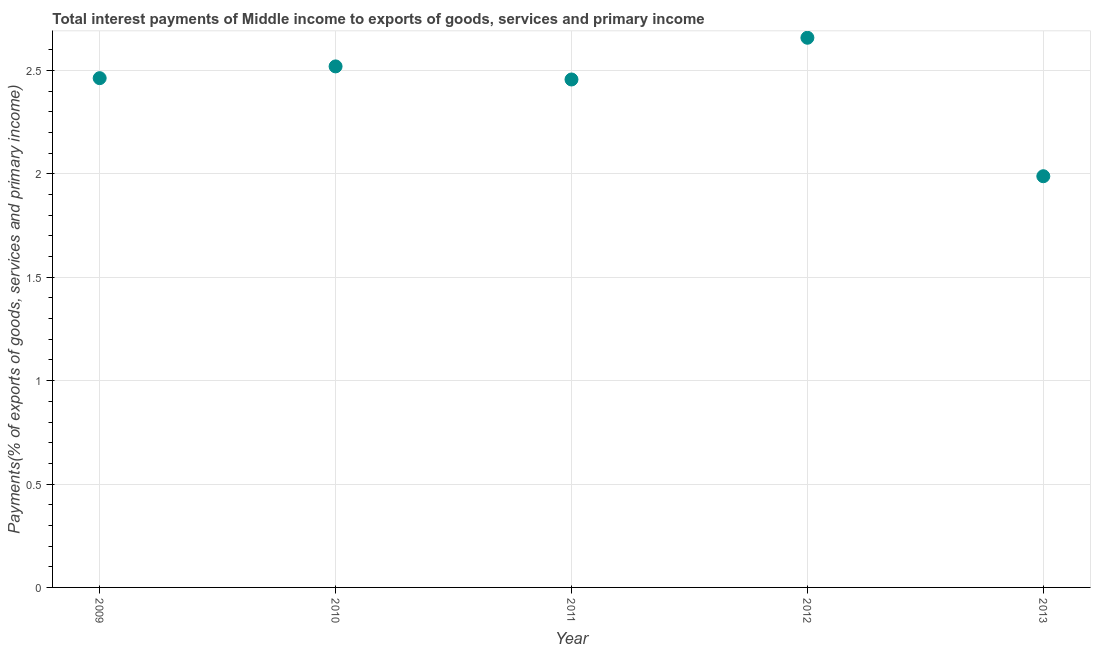What is the total interest payments on external debt in 2010?
Offer a very short reply. 2.52. Across all years, what is the maximum total interest payments on external debt?
Your response must be concise. 2.66. Across all years, what is the minimum total interest payments on external debt?
Offer a terse response. 1.99. What is the sum of the total interest payments on external debt?
Your response must be concise. 12.09. What is the difference between the total interest payments on external debt in 2009 and 2012?
Offer a very short reply. -0.2. What is the average total interest payments on external debt per year?
Your answer should be compact. 2.42. What is the median total interest payments on external debt?
Provide a short and direct response. 2.46. In how many years, is the total interest payments on external debt greater than 0.2 %?
Your answer should be very brief. 5. What is the ratio of the total interest payments on external debt in 2012 to that in 2013?
Offer a very short reply. 1.34. Is the total interest payments on external debt in 2009 less than that in 2013?
Offer a very short reply. No. What is the difference between the highest and the second highest total interest payments on external debt?
Offer a very short reply. 0.14. Is the sum of the total interest payments on external debt in 2010 and 2012 greater than the maximum total interest payments on external debt across all years?
Provide a short and direct response. Yes. What is the difference between the highest and the lowest total interest payments on external debt?
Provide a short and direct response. 0.67. Does the total interest payments on external debt monotonically increase over the years?
Offer a very short reply. No. How many dotlines are there?
Give a very brief answer. 1. How many years are there in the graph?
Provide a short and direct response. 5. Are the values on the major ticks of Y-axis written in scientific E-notation?
Ensure brevity in your answer.  No. Does the graph contain grids?
Your answer should be very brief. Yes. What is the title of the graph?
Provide a succinct answer. Total interest payments of Middle income to exports of goods, services and primary income. What is the label or title of the Y-axis?
Your response must be concise. Payments(% of exports of goods, services and primary income). What is the Payments(% of exports of goods, services and primary income) in 2009?
Ensure brevity in your answer.  2.46. What is the Payments(% of exports of goods, services and primary income) in 2010?
Offer a terse response. 2.52. What is the Payments(% of exports of goods, services and primary income) in 2011?
Offer a terse response. 2.46. What is the Payments(% of exports of goods, services and primary income) in 2012?
Your answer should be very brief. 2.66. What is the Payments(% of exports of goods, services and primary income) in 2013?
Make the answer very short. 1.99. What is the difference between the Payments(% of exports of goods, services and primary income) in 2009 and 2010?
Offer a terse response. -0.06. What is the difference between the Payments(% of exports of goods, services and primary income) in 2009 and 2011?
Your answer should be compact. 0.01. What is the difference between the Payments(% of exports of goods, services and primary income) in 2009 and 2012?
Give a very brief answer. -0.2. What is the difference between the Payments(% of exports of goods, services and primary income) in 2009 and 2013?
Provide a short and direct response. 0.47. What is the difference between the Payments(% of exports of goods, services and primary income) in 2010 and 2011?
Keep it short and to the point. 0.06. What is the difference between the Payments(% of exports of goods, services and primary income) in 2010 and 2012?
Provide a succinct answer. -0.14. What is the difference between the Payments(% of exports of goods, services and primary income) in 2010 and 2013?
Your answer should be very brief. 0.53. What is the difference between the Payments(% of exports of goods, services and primary income) in 2011 and 2012?
Your answer should be compact. -0.2. What is the difference between the Payments(% of exports of goods, services and primary income) in 2011 and 2013?
Keep it short and to the point. 0.47. What is the difference between the Payments(% of exports of goods, services and primary income) in 2012 and 2013?
Offer a very short reply. 0.67. What is the ratio of the Payments(% of exports of goods, services and primary income) in 2009 to that in 2010?
Make the answer very short. 0.98. What is the ratio of the Payments(% of exports of goods, services and primary income) in 2009 to that in 2011?
Your answer should be compact. 1. What is the ratio of the Payments(% of exports of goods, services and primary income) in 2009 to that in 2012?
Your response must be concise. 0.93. What is the ratio of the Payments(% of exports of goods, services and primary income) in 2009 to that in 2013?
Your answer should be very brief. 1.24. What is the ratio of the Payments(% of exports of goods, services and primary income) in 2010 to that in 2012?
Make the answer very short. 0.95. What is the ratio of the Payments(% of exports of goods, services and primary income) in 2010 to that in 2013?
Make the answer very short. 1.27. What is the ratio of the Payments(% of exports of goods, services and primary income) in 2011 to that in 2012?
Make the answer very short. 0.92. What is the ratio of the Payments(% of exports of goods, services and primary income) in 2011 to that in 2013?
Make the answer very short. 1.24. What is the ratio of the Payments(% of exports of goods, services and primary income) in 2012 to that in 2013?
Offer a very short reply. 1.34. 